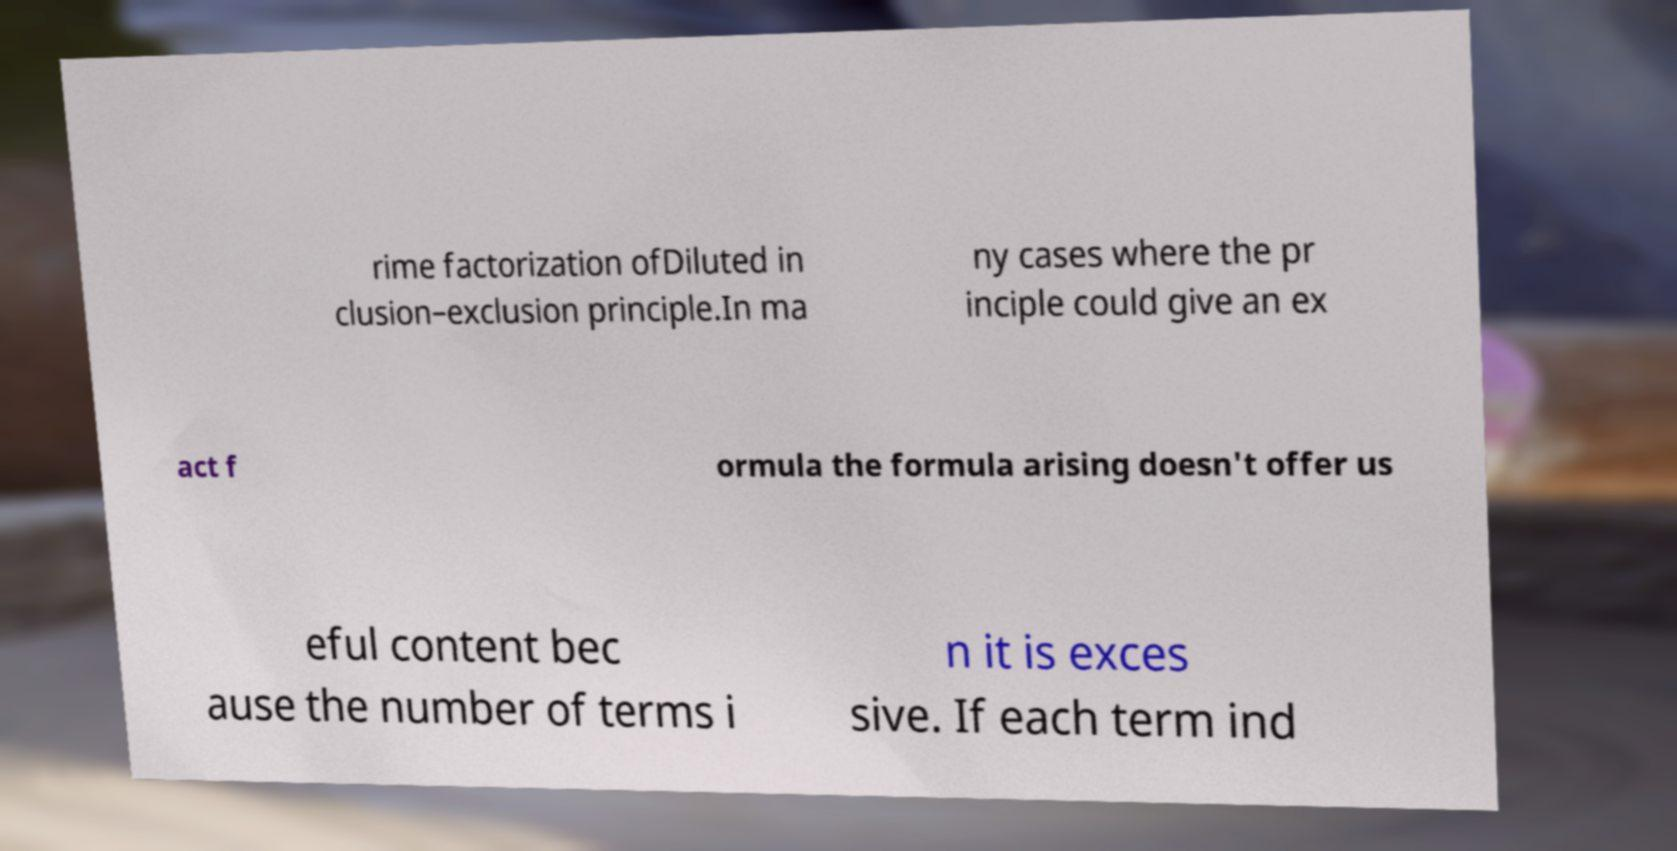For documentation purposes, I need the text within this image transcribed. Could you provide that? rime factorization ofDiluted in clusion–exclusion principle.In ma ny cases where the pr inciple could give an ex act f ormula the formula arising doesn't offer us eful content bec ause the number of terms i n it is exces sive. If each term ind 